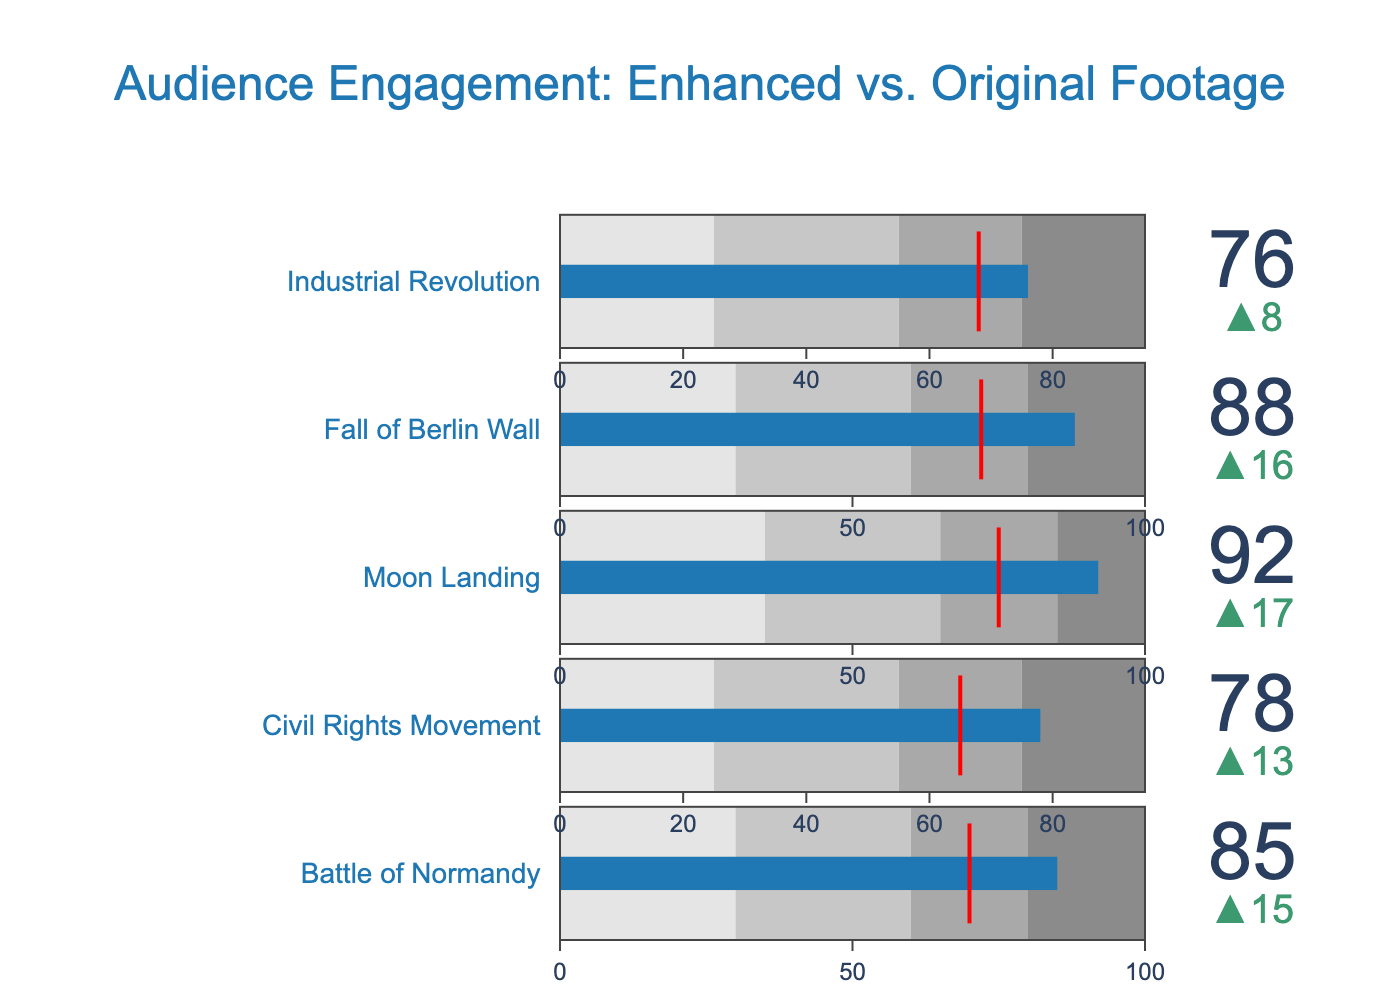What's the title of the figure? The title is prominently displayed at the top of the figure.
Answer: Audience Engagement: Enhanced vs. Original Footage What are the engagement score values for the "Moon Landing" footage section? The engagement score values can be directly read under the "Moon Landing" title in the list of bullet charts.
Answer: 92 (Enhanced), 75 (Original) How does the engagement score for the "Fall of Berlin Wall" compare to "Battle of Normandy"? The engagement score for "Fall of Berlin Wall" is 88, while for "Battle of Normandy" it is 85. By subtracting, we find that the "Fall of Berlin Wall" has a 3-point higher engagement score.
Answer: 3 points higher Which footage section has the largest difference in engagement scores between enhanced and original footage? We need to calculate the differences for each section: "Battle of Normandy" (15), "Civil Rights Movement" (13), "Moon Landing" (17), "Fall of Berlin Wall" (16), and "Industrial Revolution" (8). The "Moon Landing" has the largest difference of 17 points.
Answer: Moon Landing What range does the enhanced engagement score for the "Civil Rights Movement" fall into? The ranges for the "Civil Rights Movement" are: 25-55, 55-75, 75-95, and 95-100. The enhanced engagement score is 78, which falls in the 75-95 range.
Answer: 75-95 How many sections have their enhanced engagement scores in the highest range? The highest range for each section is: "Battle of Normandy" (80-100), "Civil Rights Movement" (75-95), "Moon Landing" (85-100), "Fall of Berlin Wall" (80-100), "Industrial Revolution" (75-95). The sections in this range are "Battle of Normandy", "Moon Landing", and "Fall of Berlin Wall".
Answer: 3 sections What is the threshold value for the "Industrial Revolution" section? The threshold value, indicated by a red line, is the original engagement score. For "Industrial Revolution", it is 68.
Answer: 68 Which footage section shows the smallest enhancement in audience engagement? Calculating the difference between enhanced and original for each section: "Battle of Normandy" (15), "Civil Rights Movement" (13), "Moon Landing" (17), "Fall of Berlin Wall" (16), and "Industrial Revolution" (8). The smallest enhancement is for the "Industrial Revolution" section.
Answer: Industrial Revolution 